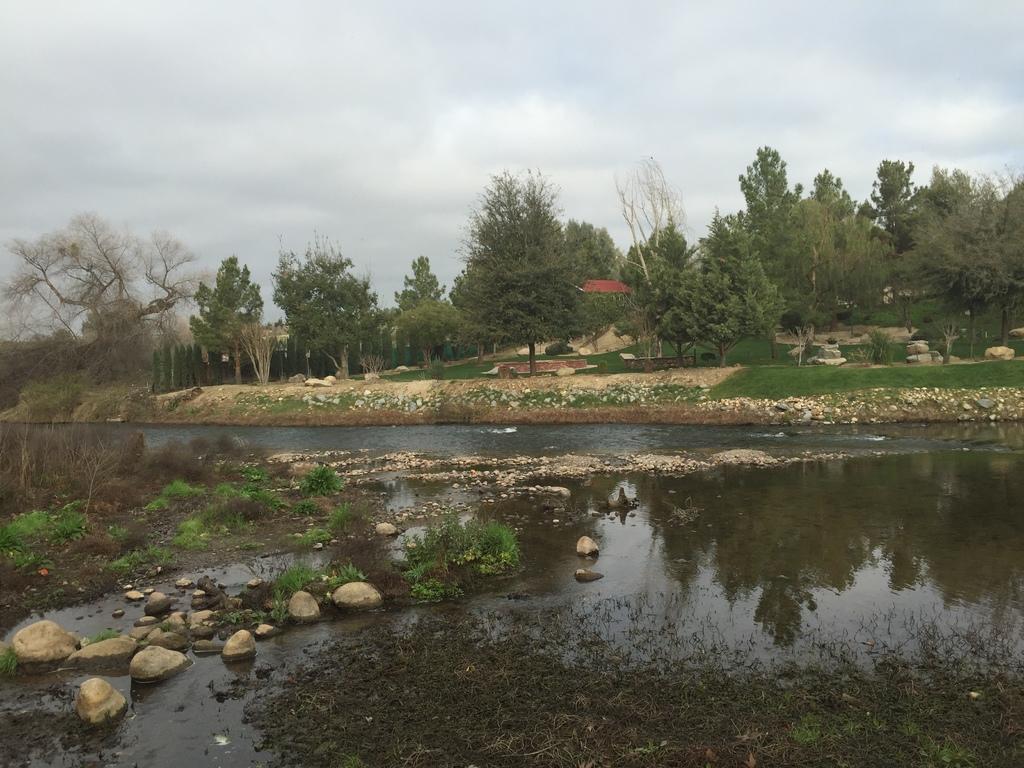How would you summarize this image in a sentence or two? In this picture there are trees. At the back it looks like a building. At the top there are clouds. At the bottom there is water and there are stones and there are plants and there is grass. 